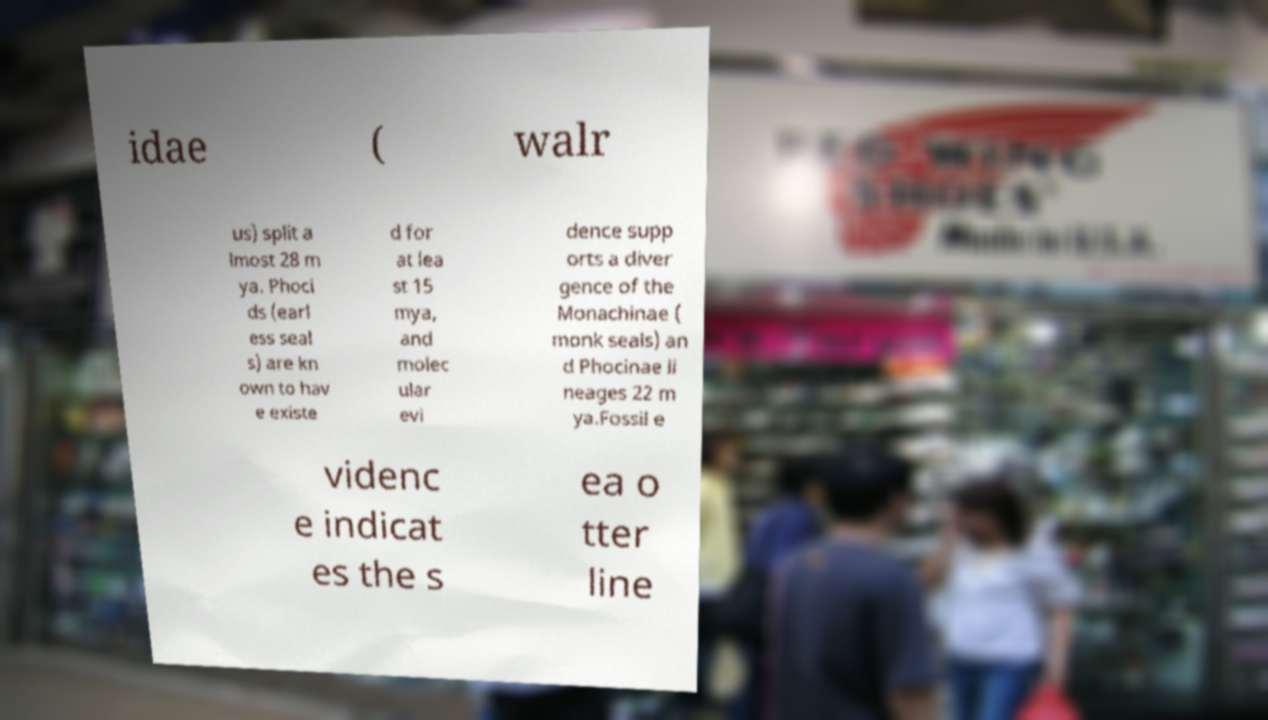For documentation purposes, I need the text within this image transcribed. Could you provide that? idae ( walr us) split a lmost 28 m ya. Phoci ds (earl ess seal s) are kn own to hav e existe d for at lea st 15 mya, and molec ular evi dence supp orts a diver gence of the Monachinae ( monk seals) an d Phocinae li neages 22 m ya.Fossil e videnc e indicat es the s ea o tter line 